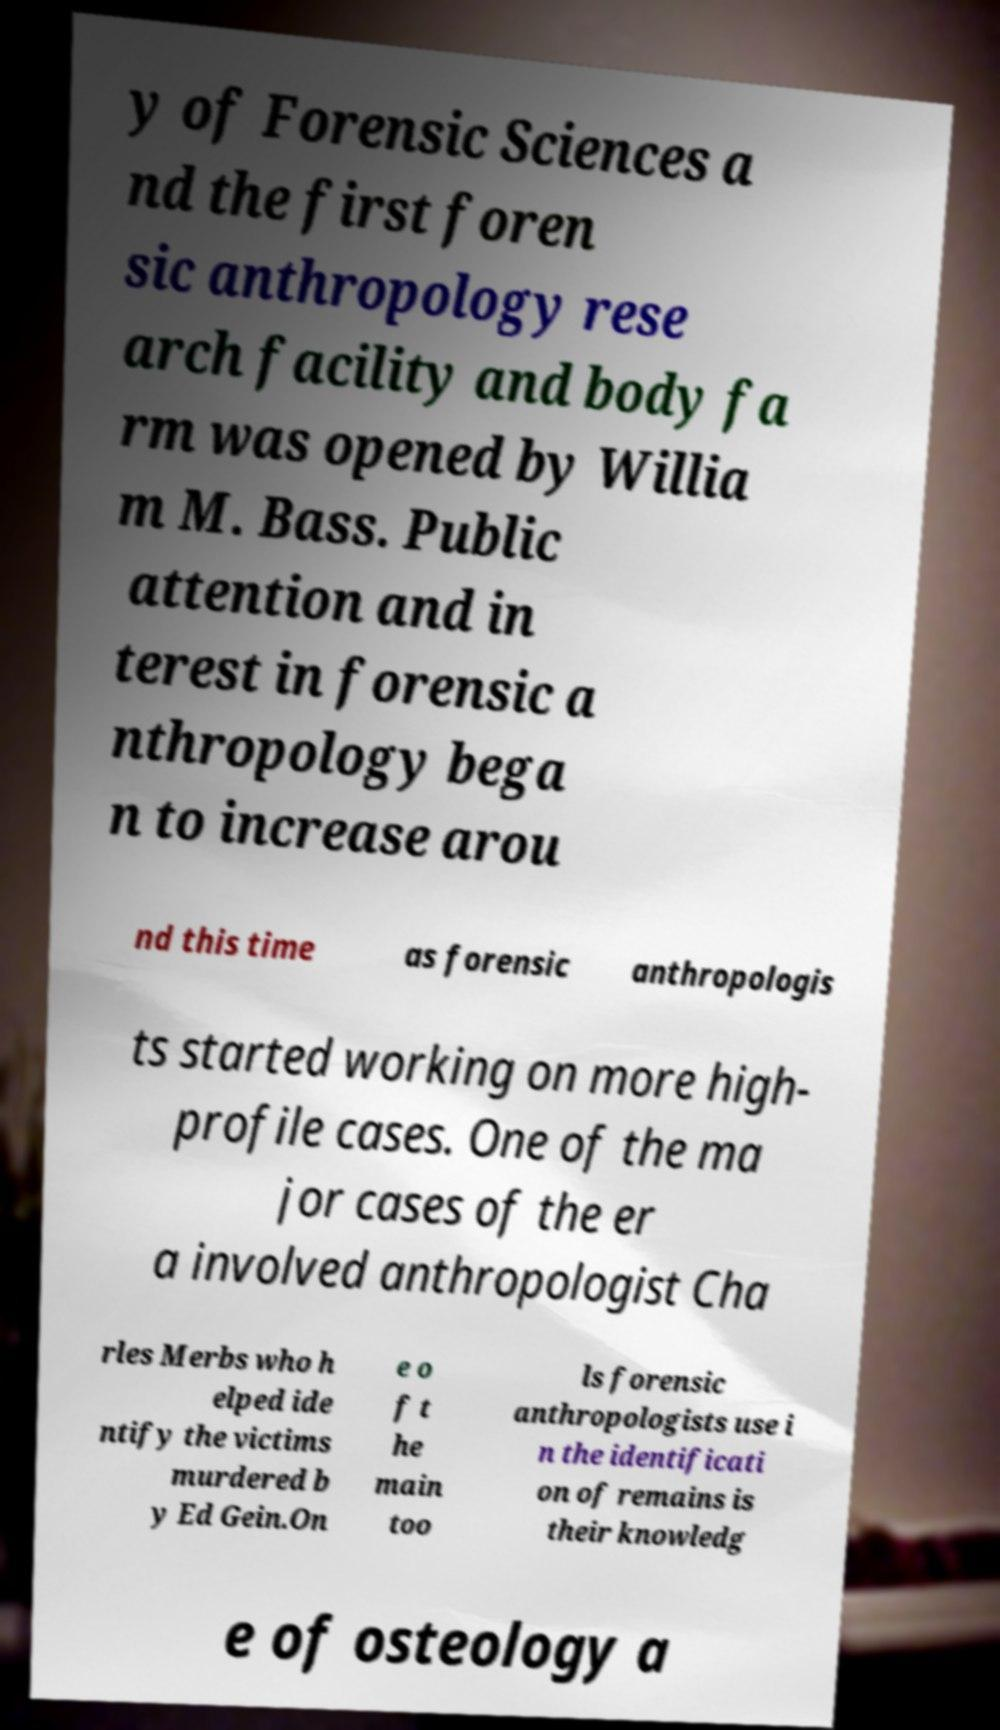Can you read and provide the text displayed in the image?This photo seems to have some interesting text. Can you extract and type it out for me? y of Forensic Sciences a nd the first foren sic anthropology rese arch facility and body fa rm was opened by Willia m M. Bass. Public attention and in terest in forensic a nthropology bega n to increase arou nd this time as forensic anthropologis ts started working on more high- profile cases. One of the ma jor cases of the er a involved anthropologist Cha rles Merbs who h elped ide ntify the victims murdered b y Ed Gein.On e o f t he main too ls forensic anthropologists use i n the identificati on of remains is their knowledg e of osteology a 